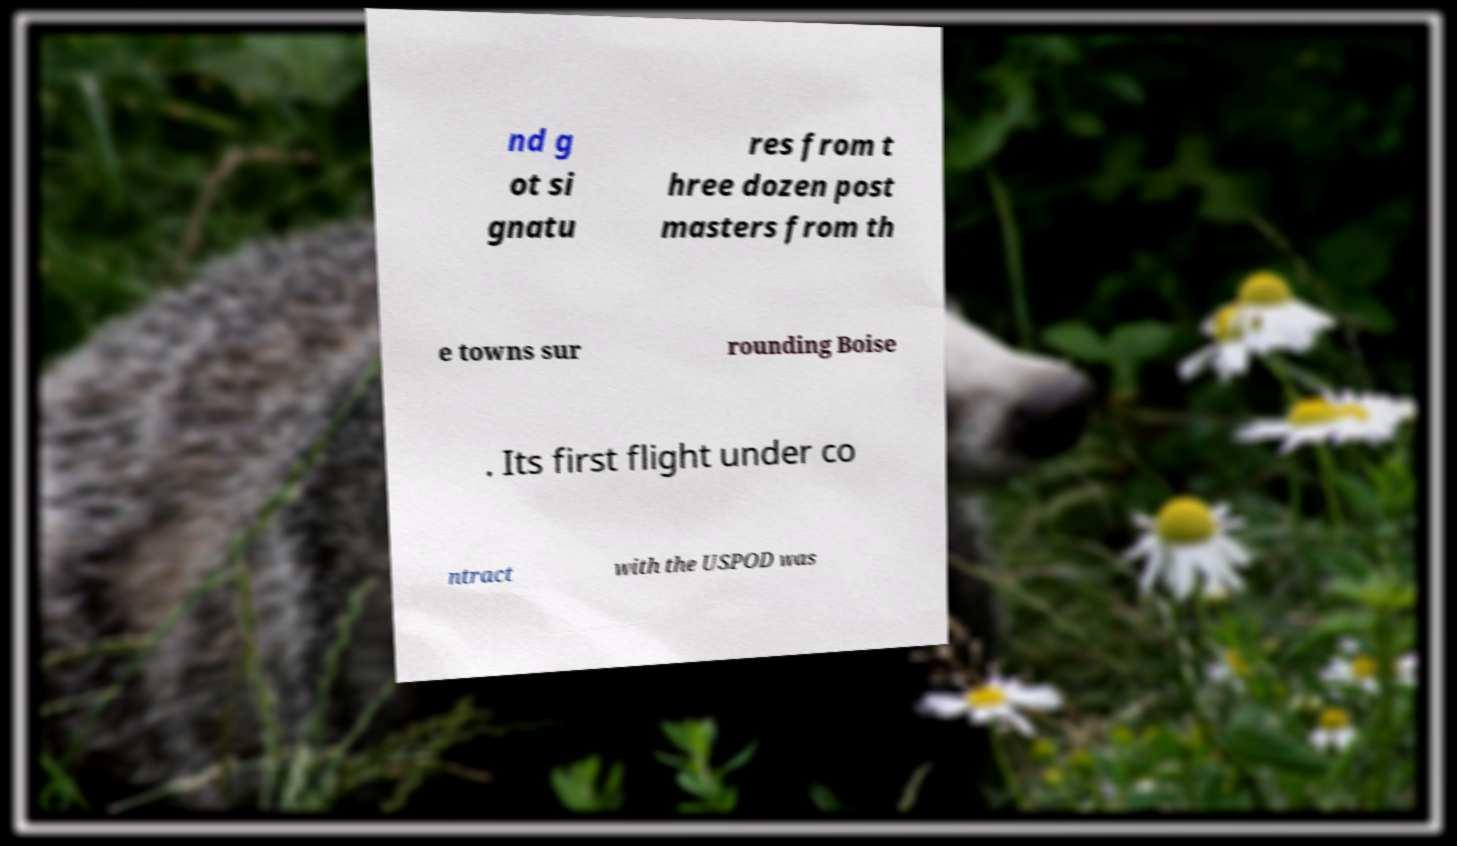Please identify and transcribe the text found in this image. nd g ot si gnatu res from t hree dozen post masters from th e towns sur rounding Boise . Its first flight under co ntract with the USPOD was 